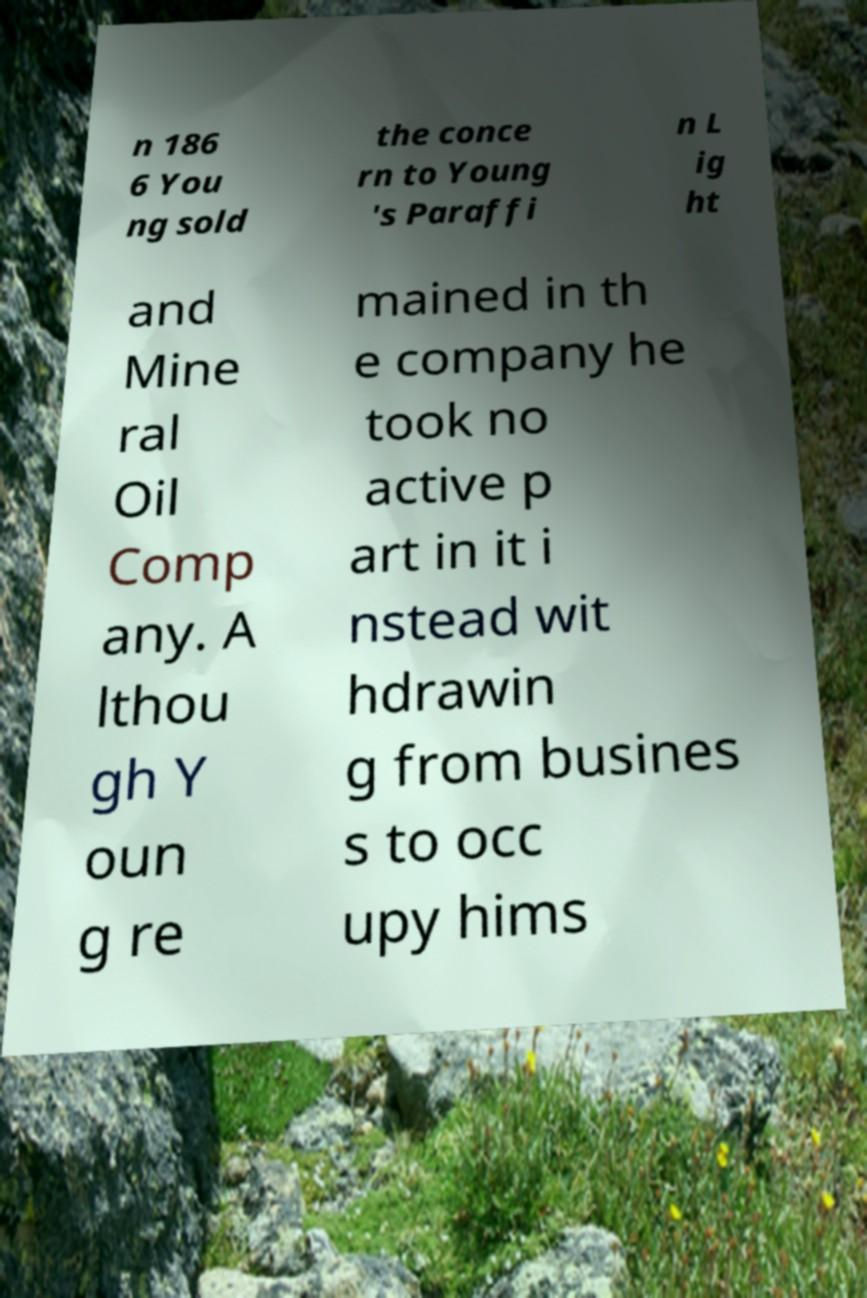Can you read and provide the text displayed in the image?This photo seems to have some interesting text. Can you extract and type it out for me? n 186 6 You ng sold the conce rn to Young 's Paraffi n L ig ht and Mine ral Oil Comp any. A lthou gh Y oun g re mained in th e company he took no active p art in it i nstead wit hdrawin g from busines s to occ upy hims 